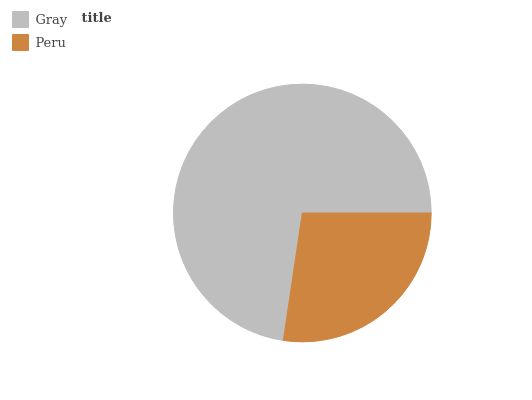Is Peru the minimum?
Answer yes or no. Yes. Is Gray the maximum?
Answer yes or no. Yes. Is Peru the maximum?
Answer yes or no. No. Is Gray greater than Peru?
Answer yes or no. Yes. Is Peru less than Gray?
Answer yes or no. Yes. Is Peru greater than Gray?
Answer yes or no. No. Is Gray less than Peru?
Answer yes or no. No. Is Gray the high median?
Answer yes or no. Yes. Is Peru the low median?
Answer yes or no. Yes. Is Peru the high median?
Answer yes or no. No. Is Gray the low median?
Answer yes or no. No. 